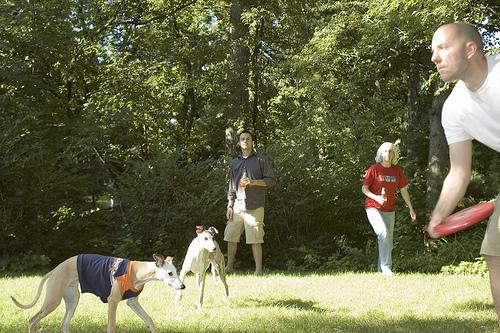Question: how many dogs are there?
Choices:
A. One.
B. None.
C. Three.
D. Two.
Answer with the letter. Answer: D Question: what are the two people in the back holding?
Choices:
A. Children.
B. Dogs.
C. Tennis rackets.
D. Beers.
Answer with the letter. Answer: D Question: what is in the background?
Choices:
A. Forest.
B. Clouds.
C. A lake.
D. Mountains.
Answer with the letter. Answer: A Question: who has on a red t-shirt?
Choices:
A. The blonde woman.
B. The older man.
C. The little girl.
D. The boy.
Answer with the letter. Answer: A Question: why is the man on the right holding a frisbee?
Choices:
A. To play with friends.
B. He is playing frisbee.
C. To clean up.
D. He is packing up his stuff at th park.
Answer with the letter. Answer: B 